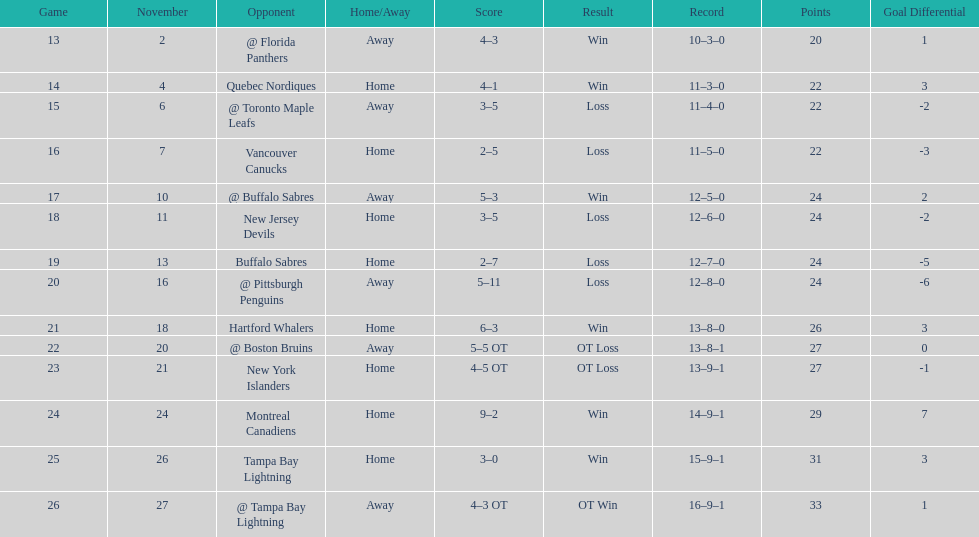What was the total penalty minutes that dave brown had on the 1993-1994 flyers? 137. 